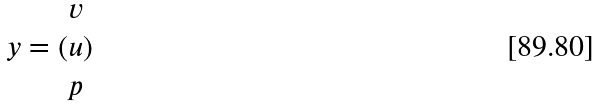Convert formula to latex. <formula><loc_0><loc_0><loc_500><loc_500>y = ( \begin{matrix} v \\ u \\ p \end{matrix} )</formula> 